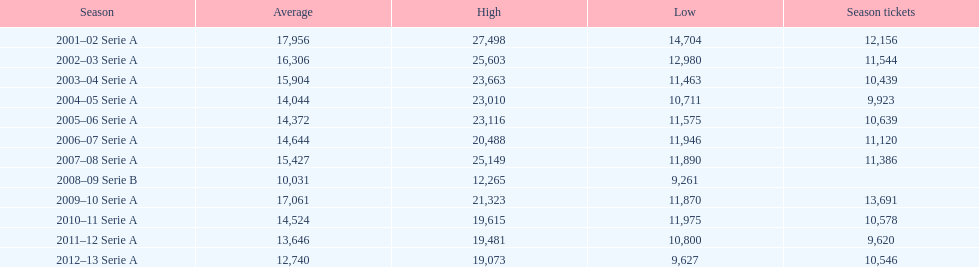In 2008, what was the typical attendance figure? 10,031. 